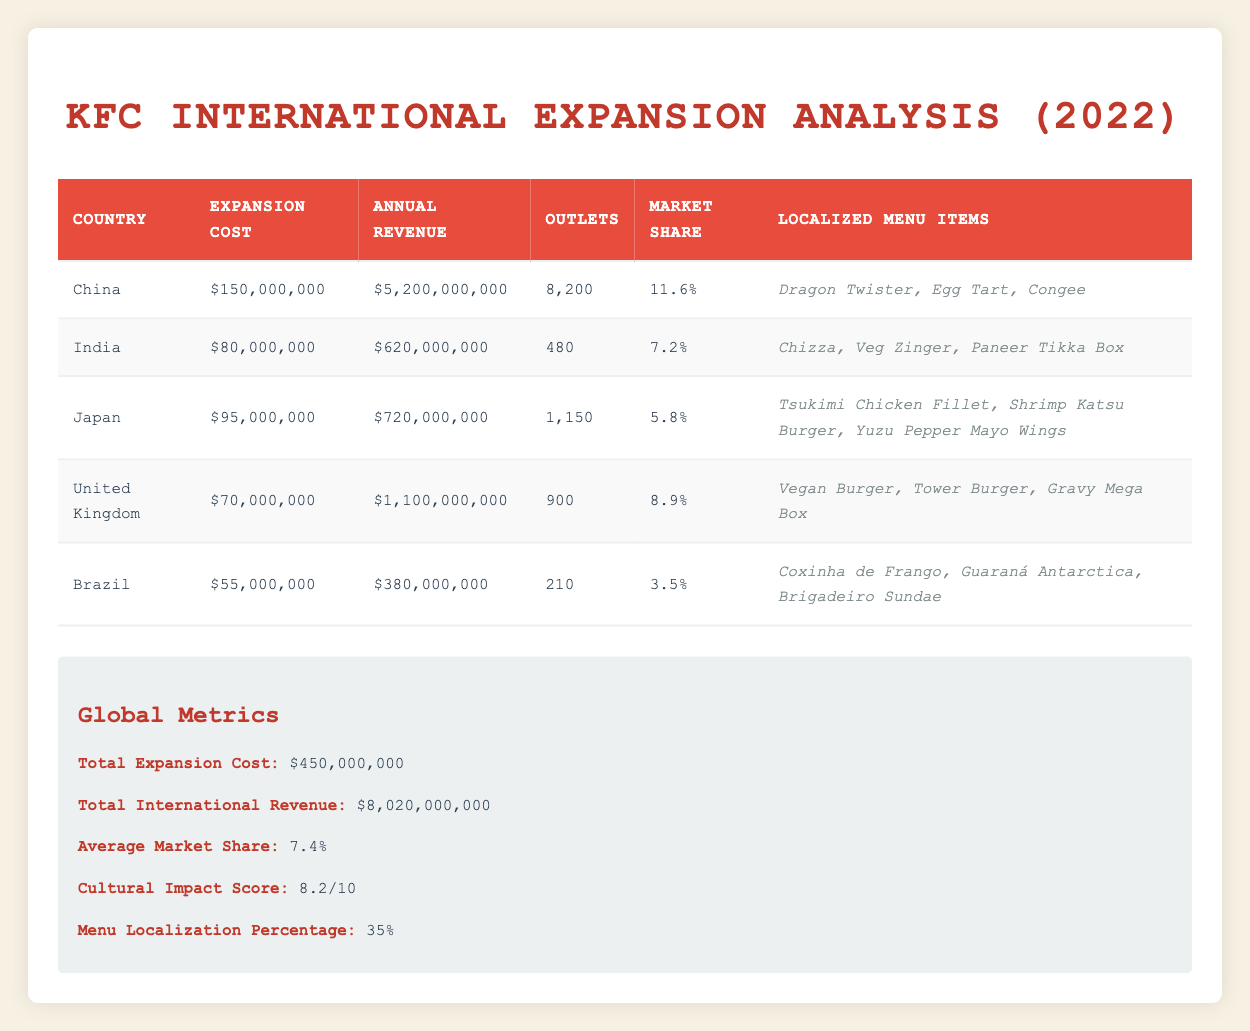What is the total expansion cost for KFC's international markets? The total expansion cost for all the countries listed in the table is already provided in the global metrics section. It can be found directly there.
Answer: 450 million dollars Which country has the highest annual revenue? By reviewing the annual revenue column, the country with the highest figure is China, which has an annual revenue of 5.2 billion dollars.
Answer: China What is the average market share across all international markets? The average market share is listed in the global metrics section, which provides the average of the market shares for all countries listed. It’s the sum of market shares divided by the number of countries, resulting in 7.4 percent.
Answer: 7.4 percent Is Brazil's expansion cost less than India's annual revenue? Brazil's expansion cost is 55 million dollars, while India's annual revenue is 620 million dollars. Since 55 million is less than 620 million, the statement is true.
Answer: Yes What is the total annual revenue from all countries combined? To find the total annual revenue, sum the annual revenues of all countries listed: (5.2 billion + 620 million + 720 million + 1.1 billion + 380 million). Converting all to the same unit gives us a total of 8.02 billion dollars.
Answer: 8.02 billion dollars Which localized menu item is available in the United Kingdom? The table shows localized menu items for each country under the respective country rows. For the United Kingdom, the items listed are Vegan Burger, Tower Burger, and Gravy Mega Box.
Answer: Vegan Burger, Tower Burger, Gravy Mega Box How much higher is China's market share compared to Brazil's market share? China's market share is 11.6 percent, and Brazil's is 3.5 percent. The difference can be calculated by subtracting Brazil's market share from China's: 11.6 - 3.5 = 8.1.
Answer: 8.1 percent Does Japan have more outlets than the United Kingdom? Japan has 1,150 outlets while the United Kingdom has 900 outlets. Since 1,150 is greater than 900, the statement is true.
Answer: Yes What percentage of KFC's menu items are localized based on this expansion? The data indicates a menu localization percentage of 35 percent, which is provided in the global metrics section of the table.
Answer: 35 percent 